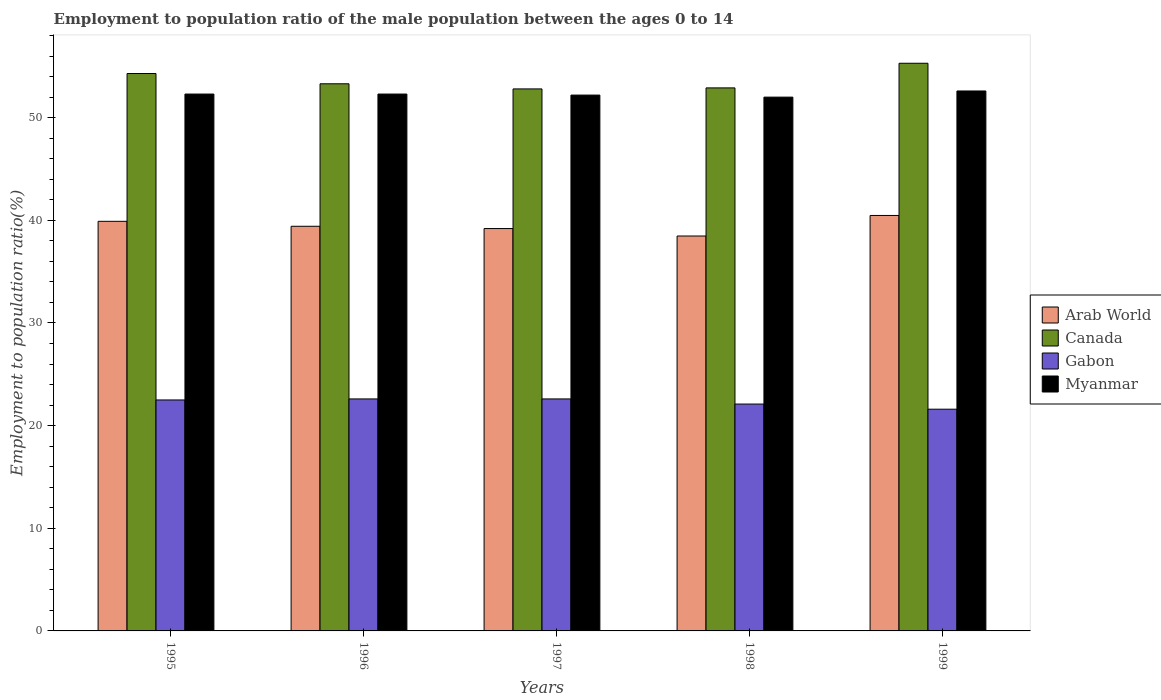How many bars are there on the 2nd tick from the left?
Your answer should be very brief. 4. What is the label of the 4th group of bars from the left?
Keep it short and to the point. 1998. In how many cases, is the number of bars for a given year not equal to the number of legend labels?
Make the answer very short. 0. What is the employment to population ratio in Myanmar in 1998?
Ensure brevity in your answer.  52. Across all years, what is the maximum employment to population ratio in Canada?
Ensure brevity in your answer.  55.3. Across all years, what is the minimum employment to population ratio in Gabon?
Provide a short and direct response. 21.6. In which year was the employment to population ratio in Canada maximum?
Provide a short and direct response. 1999. In which year was the employment to population ratio in Canada minimum?
Offer a very short reply. 1997. What is the total employment to population ratio in Myanmar in the graph?
Make the answer very short. 261.4. What is the difference between the employment to population ratio in Gabon in 1997 and the employment to population ratio in Arab World in 1995?
Keep it short and to the point. -17.3. What is the average employment to population ratio in Arab World per year?
Offer a terse response. 39.49. In the year 1999, what is the difference between the employment to population ratio in Canada and employment to population ratio in Arab World?
Provide a short and direct response. 14.83. In how many years, is the employment to population ratio in Canada greater than 20 %?
Your answer should be very brief. 5. What is the ratio of the employment to population ratio in Canada in 1997 to that in 1998?
Offer a terse response. 1. Is the difference between the employment to population ratio in Canada in 1996 and 1998 greater than the difference between the employment to population ratio in Arab World in 1996 and 1998?
Make the answer very short. No. What is the difference between the highest and the second highest employment to population ratio in Myanmar?
Your answer should be very brief. 0.3. What is the difference between the highest and the lowest employment to population ratio in Myanmar?
Make the answer very short. 0.6. In how many years, is the employment to population ratio in Myanmar greater than the average employment to population ratio in Myanmar taken over all years?
Offer a terse response. 3. What does the 2nd bar from the left in 1996 represents?
Ensure brevity in your answer.  Canada. What does the 2nd bar from the right in 1996 represents?
Make the answer very short. Gabon. Are the values on the major ticks of Y-axis written in scientific E-notation?
Make the answer very short. No. How are the legend labels stacked?
Your answer should be compact. Vertical. What is the title of the graph?
Give a very brief answer. Employment to population ratio of the male population between the ages 0 to 14. Does "Mozambique" appear as one of the legend labels in the graph?
Your answer should be very brief. No. What is the label or title of the Y-axis?
Your response must be concise. Employment to population ratio(%). What is the Employment to population ratio(%) in Arab World in 1995?
Make the answer very short. 39.9. What is the Employment to population ratio(%) of Canada in 1995?
Give a very brief answer. 54.3. What is the Employment to population ratio(%) of Myanmar in 1995?
Ensure brevity in your answer.  52.3. What is the Employment to population ratio(%) in Arab World in 1996?
Give a very brief answer. 39.42. What is the Employment to population ratio(%) of Canada in 1996?
Provide a short and direct response. 53.3. What is the Employment to population ratio(%) in Gabon in 1996?
Make the answer very short. 22.6. What is the Employment to population ratio(%) in Myanmar in 1996?
Your response must be concise. 52.3. What is the Employment to population ratio(%) of Arab World in 1997?
Provide a succinct answer. 39.2. What is the Employment to population ratio(%) in Canada in 1997?
Your response must be concise. 52.8. What is the Employment to population ratio(%) in Gabon in 1997?
Offer a very short reply. 22.6. What is the Employment to population ratio(%) of Myanmar in 1997?
Provide a short and direct response. 52.2. What is the Employment to population ratio(%) in Arab World in 1998?
Offer a terse response. 38.47. What is the Employment to population ratio(%) in Canada in 1998?
Provide a succinct answer. 52.9. What is the Employment to population ratio(%) in Gabon in 1998?
Your response must be concise. 22.1. What is the Employment to population ratio(%) of Myanmar in 1998?
Your answer should be very brief. 52. What is the Employment to population ratio(%) in Arab World in 1999?
Give a very brief answer. 40.47. What is the Employment to population ratio(%) in Canada in 1999?
Provide a succinct answer. 55.3. What is the Employment to population ratio(%) in Gabon in 1999?
Give a very brief answer. 21.6. What is the Employment to population ratio(%) in Myanmar in 1999?
Offer a very short reply. 52.6. Across all years, what is the maximum Employment to population ratio(%) in Arab World?
Ensure brevity in your answer.  40.47. Across all years, what is the maximum Employment to population ratio(%) of Canada?
Give a very brief answer. 55.3. Across all years, what is the maximum Employment to population ratio(%) of Gabon?
Ensure brevity in your answer.  22.6. Across all years, what is the maximum Employment to population ratio(%) of Myanmar?
Your answer should be very brief. 52.6. Across all years, what is the minimum Employment to population ratio(%) of Arab World?
Keep it short and to the point. 38.47. Across all years, what is the minimum Employment to population ratio(%) in Canada?
Make the answer very short. 52.8. Across all years, what is the minimum Employment to population ratio(%) in Gabon?
Offer a very short reply. 21.6. Across all years, what is the minimum Employment to population ratio(%) in Myanmar?
Your response must be concise. 52. What is the total Employment to population ratio(%) of Arab World in the graph?
Provide a short and direct response. 197.46. What is the total Employment to population ratio(%) of Canada in the graph?
Provide a succinct answer. 268.6. What is the total Employment to population ratio(%) in Gabon in the graph?
Make the answer very short. 111.4. What is the total Employment to population ratio(%) of Myanmar in the graph?
Make the answer very short. 261.4. What is the difference between the Employment to population ratio(%) in Arab World in 1995 and that in 1996?
Make the answer very short. 0.48. What is the difference between the Employment to population ratio(%) in Canada in 1995 and that in 1996?
Give a very brief answer. 1. What is the difference between the Employment to population ratio(%) in Arab World in 1995 and that in 1997?
Offer a very short reply. 0.7. What is the difference between the Employment to population ratio(%) in Canada in 1995 and that in 1997?
Your answer should be very brief. 1.5. What is the difference between the Employment to population ratio(%) of Gabon in 1995 and that in 1997?
Keep it short and to the point. -0.1. What is the difference between the Employment to population ratio(%) in Myanmar in 1995 and that in 1997?
Your answer should be very brief. 0.1. What is the difference between the Employment to population ratio(%) of Arab World in 1995 and that in 1998?
Your answer should be very brief. 1.43. What is the difference between the Employment to population ratio(%) of Gabon in 1995 and that in 1998?
Your response must be concise. 0.4. What is the difference between the Employment to population ratio(%) of Arab World in 1995 and that in 1999?
Offer a very short reply. -0.57. What is the difference between the Employment to population ratio(%) of Gabon in 1995 and that in 1999?
Offer a very short reply. 0.9. What is the difference between the Employment to population ratio(%) in Myanmar in 1995 and that in 1999?
Your answer should be compact. -0.3. What is the difference between the Employment to population ratio(%) of Arab World in 1996 and that in 1997?
Make the answer very short. 0.22. What is the difference between the Employment to population ratio(%) in Canada in 1996 and that in 1997?
Make the answer very short. 0.5. What is the difference between the Employment to population ratio(%) of Gabon in 1996 and that in 1997?
Offer a very short reply. 0. What is the difference between the Employment to population ratio(%) of Myanmar in 1996 and that in 1997?
Your answer should be very brief. 0.1. What is the difference between the Employment to population ratio(%) of Arab World in 1996 and that in 1998?
Keep it short and to the point. 0.95. What is the difference between the Employment to population ratio(%) in Canada in 1996 and that in 1998?
Offer a terse response. 0.4. What is the difference between the Employment to population ratio(%) in Arab World in 1996 and that in 1999?
Make the answer very short. -1.05. What is the difference between the Employment to population ratio(%) of Canada in 1996 and that in 1999?
Make the answer very short. -2. What is the difference between the Employment to population ratio(%) in Arab World in 1997 and that in 1998?
Give a very brief answer. 0.73. What is the difference between the Employment to population ratio(%) of Canada in 1997 and that in 1998?
Ensure brevity in your answer.  -0.1. What is the difference between the Employment to population ratio(%) of Myanmar in 1997 and that in 1998?
Your answer should be very brief. 0.2. What is the difference between the Employment to population ratio(%) of Arab World in 1997 and that in 1999?
Keep it short and to the point. -1.27. What is the difference between the Employment to population ratio(%) of Myanmar in 1997 and that in 1999?
Your answer should be compact. -0.4. What is the difference between the Employment to population ratio(%) of Arab World in 1998 and that in 1999?
Keep it short and to the point. -2. What is the difference between the Employment to population ratio(%) in Canada in 1998 and that in 1999?
Provide a succinct answer. -2.4. What is the difference between the Employment to population ratio(%) of Arab World in 1995 and the Employment to population ratio(%) of Canada in 1996?
Your response must be concise. -13.4. What is the difference between the Employment to population ratio(%) of Arab World in 1995 and the Employment to population ratio(%) of Gabon in 1996?
Provide a succinct answer. 17.3. What is the difference between the Employment to population ratio(%) of Arab World in 1995 and the Employment to population ratio(%) of Myanmar in 1996?
Give a very brief answer. -12.4. What is the difference between the Employment to population ratio(%) in Canada in 1995 and the Employment to population ratio(%) in Gabon in 1996?
Ensure brevity in your answer.  31.7. What is the difference between the Employment to population ratio(%) in Gabon in 1995 and the Employment to population ratio(%) in Myanmar in 1996?
Your answer should be very brief. -29.8. What is the difference between the Employment to population ratio(%) of Arab World in 1995 and the Employment to population ratio(%) of Canada in 1997?
Offer a very short reply. -12.9. What is the difference between the Employment to population ratio(%) in Arab World in 1995 and the Employment to population ratio(%) in Gabon in 1997?
Provide a short and direct response. 17.3. What is the difference between the Employment to population ratio(%) of Arab World in 1995 and the Employment to population ratio(%) of Myanmar in 1997?
Give a very brief answer. -12.3. What is the difference between the Employment to population ratio(%) in Canada in 1995 and the Employment to population ratio(%) in Gabon in 1997?
Offer a terse response. 31.7. What is the difference between the Employment to population ratio(%) of Gabon in 1995 and the Employment to population ratio(%) of Myanmar in 1997?
Offer a terse response. -29.7. What is the difference between the Employment to population ratio(%) of Arab World in 1995 and the Employment to population ratio(%) of Canada in 1998?
Make the answer very short. -13. What is the difference between the Employment to population ratio(%) of Arab World in 1995 and the Employment to population ratio(%) of Gabon in 1998?
Your answer should be compact. 17.8. What is the difference between the Employment to population ratio(%) in Arab World in 1995 and the Employment to population ratio(%) in Myanmar in 1998?
Offer a terse response. -12.1. What is the difference between the Employment to population ratio(%) in Canada in 1995 and the Employment to population ratio(%) in Gabon in 1998?
Your response must be concise. 32.2. What is the difference between the Employment to population ratio(%) of Canada in 1995 and the Employment to population ratio(%) of Myanmar in 1998?
Provide a succinct answer. 2.3. What is the difference between the Employment to population ratio(%) in Gabon in 1995 and the Employment to population ratio(%) in Myanmar in 1998?
Your answer should be very brief. -29.5. What is the difference between the Employment to population ratio(%) in Arab World in 1995 and the Employment to population ratio(%) in Canada in 1999?
Provide a short and direct response. -15.4. What is the difference between the Employment to population ratio(%) in Arab World in 1995 and the Employment to population ratio(%) in Gabon in 1999?
Keep it short and to the point. 18.3. What is the difference between the Employment to population ratio(%) of Arab World in 1995 and the Employment to population ratio(%) of Myanmar in 1999?
Offer a very short reply. -12.7. What is the difference between the Employment to population ratio(%) of Canada in 1995 and the Employment to population ratio(%) of Gabon in 1999?
Offer a terse response. 32.7. What is the difference between the Employment to population ratio(%) of Canada in 1995 and the Employment to population ratio(%) of Myanmar in 1999?
Make the answer very short. 1.7. What is the difference between the Employment to population ratio(%) in Gabon in 1995 and the Employment to population ratio(%) in Myanmar in 1999?
Offer a very short reply. -30.1. What is the difference between the Employment to population ratio(%) in Arab World in 1996 and the Employment to population ratio(%) in Canada in 1997?
Your answer should be compact. -13.38. What is the difference between the Employment to population ratio(%) of Arab World in 1996 and the Employment to population ratio(%) of Gabon in 1997?
Make the answer very short. 16.82. What is the difference between the Employment to population ratio(%) of Arab World in 1996 and the Employment to population ratio(%) of Myanmar in 1997?
Make the answer very short. -12.78. What is the difference between the Employment to population ratio(%) in Canada in 1996 and the Employment to population ratio(%) in Gabon in 1997?
Your answer should be very brief. 30.7. What is the difference between the Employment to population ratio(%) in Canada in 1996 and the Employment to population ratio(%) in Myanmar in 1997?
Offer a very short reply. 1.1. What is the difference between the Employment to population ratio(%) of Gabon in 1996 and the Employment to population ratio(%) of Myanmar in 1997?
Offer a very short reply. -29.6. What is the difference between the Employment to population ratio(%) in Arab World in 1996 and the Employment to population ratio(%) in Canada in 1998?
Make the answer very short. -13.48. What is the difference between the Employment to population ratio(%) of Arab World in 1996 and the Employment to population ratio(%) of Gabon in 1998?
Make the answer very short. 17.32. What is the difference between the Employment to population ratio(%) of Arab World in 1996 and the Employment to population ratio(%) of Myanmar in 1998?
Make the answer very short. -12.58. What is the difference between the Employment to population ratio(%) of Canada in 1996 and the Employment to population ratio(%) of Gabon in 1998?
Provide a short and direct response. 31.2. What is the difference between the Employment to population ratio(%) of Canada in 1996 and the Employment to population ratio(%) of Myanmar in 1998?
Your response must be concise. 1.3. What is the difference between the Employment to population ratio(%) of Gabon in 1996 and the Employment to population ratio(%) of Myanmar in 1998?
Make the answer very short. -29.4. What is the difference between the Employment to population ratio(%) in Arab World in 1996 and the Employment to population ratio(%) in Canada in 1999?
Make the answer very short. -15.88. What is the difference between the Employment to population ratio(%) in Arab World in 1996 and the Employment to population ratio(%) in Gabon in 1999?
Your answer should be very brief. 17.82. What is the difference between the Employment to population ratio(%) in Arab World in 1996 and the Employment to population ratio(%) in Myanmar in 1999?
Your response must be concise. -13.18. What is the difference between the Employment to population ratio(%) in Canada in 1996 and the Employment to population ratio(%) in Gabon in 1999?
Ensure brevity in your answer.  31.7. What is the difference between the Employment to population ratio(%) of Arab World in 1997 and the Employment to population ratio(%) of Canada in 1998?
Provide a succinct answer. -13.7. What is the difference between the Employment to population ratio(%) of Arab World in 1997 and the Employment to population ratio(%) of Gabon in 1998?
Give a very brief answer. 17.1. What is the difference between the Employment to population ratio(%) of Arab World in 1997 and the Employment to population ratio(%) of Myanmar in 1998?
Ensure brevity in your answer.  -12.8. What is the difference between the Employment to population ratio(%) in Canada in 1997 and the Employment to population ratio(%) in Gabon in 1998?
Your answer should be very brief. 30.7. What is the difference between the Employment to population ratio(%) in Canada in 1997 and the Employment to population ratio(%) in Myanmar in 1998?
Provide a succinct answer. 0.8. What is the difference between the Employment to population ratio(%) of Gabon in 1997 and the Employment to population ratio(%) of Myanmar in 1998?
Your answer should be very brief. -29.4. What is the difference between the Employment to population ratio(%) in Arab World in 1997 and the Employment to population ratio(%) in Canada in 1999?
Your answer should be compact. -16.1. What is the difference between the Employment to population ratio(%) in Arab World in 1997 and the Employment to population ratio(%) in Gabon in 1999?
Your answer should be compact. 17.6. What is the difference between the Employment to population ratio(%) of Arab World in 1997 and the Employment to population ratio(%) of Myanmar in 1999?
Ensure brevity in your answer.  -13.4. What is the difference between the Employment to population ratio(%) of Canada in 1997 and the Employment to population ratio(%) of Gabon in 1999?
Your answer should be very brief. 31.2. What is the difference between the Employment to population ratio(%) of Gabon in 1997 and the Employment to population ratio(%) of Myanmar in 1999?
Provide a succinct answer. -30. What is the difference between the Employment to population ratio(%) in Arab World in 1998 and the Employment to population ratio(%) in Canada in 1999?
Ensure brevity in your answer.  -16.83. What is the difference between the Employment to population ratio(%) of Arab World in 1998 and the Employment to population ratio(%) of Gabon in 1999?
Provide a succinct answer. 16.87. What is the difference between the Employment to population ratio(%) of Arab World in 1998 and the Employment to population ratio(%) of Myanmar in 1999?
Give a very brief answer. -14.13. What is the difference between the Employment to population ratio(%) in Canada in 1998 and the Employment to population ratio(%) in Gabon in 1999?
Your response must be concise. 31.3. What is the difference between the Employment to population ratio(%) of Gabon in 1998 and the Employment to population ratio(%) of Myanmar in 1999?
Your answer should be very brief. -30.5. What is the average Employment to population ratio(%) in Arab World per year?
Give a very brief answer. 39.49. What is the average Employment to population ratio(%) of Canada per year?
Offer a very short reply. 53.72. What is the average Employment to population ratio(%) in Gabon per year?
Offer a terse response. 22.28. What is the average Employment to population ratio(%) in Myanmar per year?
Your response must be concise. 52.28. In the year 1995, what is the difference between the Employment to population ratio(%) of Arab World and Employment to population ratio(%) of Canada?
Provide a succinct answer. -14.4. In the year 1995, what is the difference between the Employment to population ratio(%) in Arab World and Employment to population ratio(%) in Gabon?
Keep it short and to the point. 17.4. In the year 1995, what is the difference between the Employment to population ratio(%) in Arab World and Employment to population ratio(%) in Myanmar?
Keep it short and to the point. -12.4. In the year 1995, what is the difference between the Employment to population ratio(%) of Canada and Employment to population ratio(%) of Gabon?
Make the answer very short. 31.8. In the year 1995, what is the difference between the Employment to population ratio(%) in Gabon and Employment to population ratio(%) in Myanmar?
Offer a very short reply. -29.8. In the year 1996, what is the difference between the Employment to population ratio(%) of Arab World and Employment to population ratio(%) of Canada?
Your response must be concise. -13.88. In the year 1996, what is the difference between the Employment to population ratio(%) of Arab World and Employment to population ratio(%) of Gabon?
Your response must be concise. 16.82. In the year 1996, what is the difference between the Employment to population ratio(%) of Arab World and Employment to population ratio(%) of Myanmar?
Your answer should be compact. -12.88. In the year 1996, what is the difference between the Employment to population ratio(%) of Canada and Employment to population ratio(%) of Gabon?
Offer a very short reply. 30.7. In the year 1996, what is the difference between the Employment to population ratio(%) in Gabon and Employment to population ratio(%) in Myanmar?
Your response must be concise. -29.7. In the year 1997, what is the difference between the Employment to population ratio(%) in Arab World and Employment to population ratio(%) in Canada?
Give a very brief answer. -13.6. In the year 1997, what is the difference between the Employment to population ratio(%) of Arab World and Employment to population ratio(%) of Gabon?
Your answer should be compact. 16.6. In the year 1997, what is the difference between the Employment to population ratio(%) in Arab World and Employment to population ratio(%) in Myanmar?
Your answer should be compact. -13. In the year 1997, what is the difference between the Employment to population ratio(%) of Canada and Employment to population ratio(%) of Gabon?
Provide a short and direct response. 30.2. In the year 1997, what is the difference between the Employment to population ratio(%) of Canada and Employment to population ratio(%) of Myanmar?
Provide a short and direct response. 0.6. In the year 1997, what is the difference between the Employment to population ratio(%) in Gabon and Employment to population ratio(%) in Myanmar?
Your answer should be compact. -29.6. In the year 1998, what is the difference between the Employment to population ratio(%) of Arab World and Employment to population ratio(%) of Canada?
Provide a short and direct response. -14.43. In the year 1998, what is the difference between the Employment to population ratio(%) of Arab World and Employment to population ratio(%) of Gabon?
Your answer should be compact. 16.37. In the year 1998, what is the difference between the Employment to population ratio(%) of Arab World and Employment to population ratio(%) of Myanmar?
Your answer should be compact. -13.53. In the year 1998, what is the difference between the Employment to population ratio(%) of Canada and Employment to population ratio(%) of Gabon?
Your answer should be very brief. 30.8. In the year 1998, what is the difference between the Employment to population ratio(%) in Gabon and Employment to population ratio(%) in Myanmar?
Ensure brevity in your answer.  -29.9. In the year 1999, what is the difference between the Employment to population ratio(%) of Arab World and Employment to population ratio(%) of Canada?
Your response must be concise. -14.83. In the year 1999, what is the difference between the Employment to population ratio(%) in Arab World and Employment to population ratio(%) in Gabon?
Ensure brevity in your answer.  18.87. In the year 1999, what is the difference between the Employment to population ratio(%) of Arab World and Employment to population ratio(%) of Myanmar?
Provide a short and direct response. -12.13. In the year 1999, what is the difference between the Employment to population ratio(%) of Canada and Employment to population ratio(%) of Gabon?
Your answer should be compact. 33.7. In the year 1999, what is the difference between the Employment to population ratio(%) in Canada and Employment to population ratio(%) in Myanmar?
Offer a terse response. 2.7. In the year 1999, what is the difference between the Employment to population ratio(%) of Gabon and Employment to population ratio(%) of Myanmar?
Your response must be concise. -31. What is the ratio of the Employment to population ratio(%) of Arab World in 1995 to that in 1996?
Make the answer very short. 1.01. What is the ratio of the Employment to population ratio(%) in Canada in 1995 to that in 1996?
Offer a very short reply. 1.02. What is the ratio of the Employment to population ratio(%) of Arab World in 1995 to that in 1997?
Offer a terse response. 1.02. What is the ratio of the Employment to population ratio(%) in Canada in 1995 to that in 1997?
Provide a short and direct response. 1.03. What is the ratio of the Employment to population ratio(%) in Myanmar in 1995 to that in 1997?
Keep it short and to the point. 1. What is the ratio of the Employment to population ratio(%) in Arab World in 1995 to that in 1998?
Offer a very short reply. 1.04. What is the ratio of the Employment to population ratio(%) of Canada in 1995 to that in 1998?
Make the answer very short. 1.03. What is the ratio of the Employment to population ratio(%) in Gabon in 1995 to that in 1998?
Make the answer very short. 1.02. What is the ratio of the Employment to population ratio(%) in Myanmar in 1995 to that in 1998?
Provide a short and direct response. 1.01. What is the ratio of the Employment to population ratio(%) of Arab World in 1995 to that in 1999?
Your answer should be very brief. 0.99. What is the ratio of the Employment to population ratio(%) in Canada in 1995 to that in 1999?
Your answer should be very brief. 0.98. What is the ratio of the Employment to population ratio(%) in Gabon in 1995 to that in 1999?
Your answer should be compact. 1.04. What is the ratio of the Employment to population ratio(%) in Myanmar in 1995 to that in 1999?
Provide a succinct answer. 0.99. What is the ratio of the Employment to population ratio(%) in Arab World in 1996 to that in 1997?
Offer a very short reply. 1.01. What is the ratio of the Employment to population ratio(%) of Canada in 1996 to that in 1997?
Provide a succinct answer. 1.01. What is the ratio of the Employment to population ratio(%) of Myanmar in 1996 to that in 1997?
Your answer should be very brief. 1. What is the ratio of the Employment to population ratio(%) in Arab World in 1996 to that in 1998?
Offer a terse response. 1.02. What is the ratio of the Employment to population ratio(%) of Canada in 1996 to that in 1998?
Your response must be concise. 1.01. What is the ratio of the Employment to population ratio(%) of Gabon in 1996 to that in 1998?
Provide a short and direct response. 1.02. What is the ratio of the Employment to population ratio(%) of Canada in 1996 to that in 1999?
Give a very brief answer. 0.96. What is the ratio of the Employment to population ratio(%) in Gabon in 1996 to that in 1999?
Offer a very short reply. 1.05. What is the ratio of the Employment to population ratio(%) in Myanmar in 1996 to that in 1999?
Your answer should be very brief. 0.99. What is the ratio of the Employment to population ratio(%) of Arab World in 1997 to that in 1998?
Offer a very short reply. 1.02. What is the ratio of the Employment to population ratio(%) in Gabon in 1997 to that in 1998?
Your answer should be very brief. 1.02. What is the ratio of the Employment to population ratio(%) of Myanmar in 1997 to that in 1998?
Keep it short and to the point. 1. What is the ratio of the Employment to population ratio(%) of Arab World in 1997 to that in 1999?
Ensure brevity in your answer.  0.97. What is the ratio of the Employment to population ratio(%) of Canada in 1997 to that in 1999?
Your answer should be very brief. 0.95. What is the ratio of the Employment to population ratio(%) of Gabon in 1997 to that in 1999?
Make the answer very short. 1.05. What is the ratio of the Employment to population ratio(%) of Arab World in 1998 to that in 1999?
Provide a succinct answer. 0.95. What is the ratio of the Employment to population ratio(%) in Canada in 1998 to that in 1999?
Make the answer very short. 0.96. What is the ratio of the Employment to population ratio(%) of Gabon in 1998 to that in 1999?
Your response must be concise. 1.02. What is the ratio of the Employment to population ratio(%) of Myanmar in 1998 to that in 1999?
Your answer should be compact. 0.99. What is the difference between the highest and the second highest Employment to population ratio(%) in Arab World?
Offer a terse response. 0.57. What is the difference between the highest and the second highest Employment to population ratio(%) of Myanmar?
Ensure brevity in your answer.  0.3. What is the difference between the highest and the lowest Employment to population ratio(%) in Arab World?
Keep it short and to the point. 2. What is the difference between the highest and the lowest Employment to population ratio(%) in Myanmar?
Give a very brief answer. 0.6. 